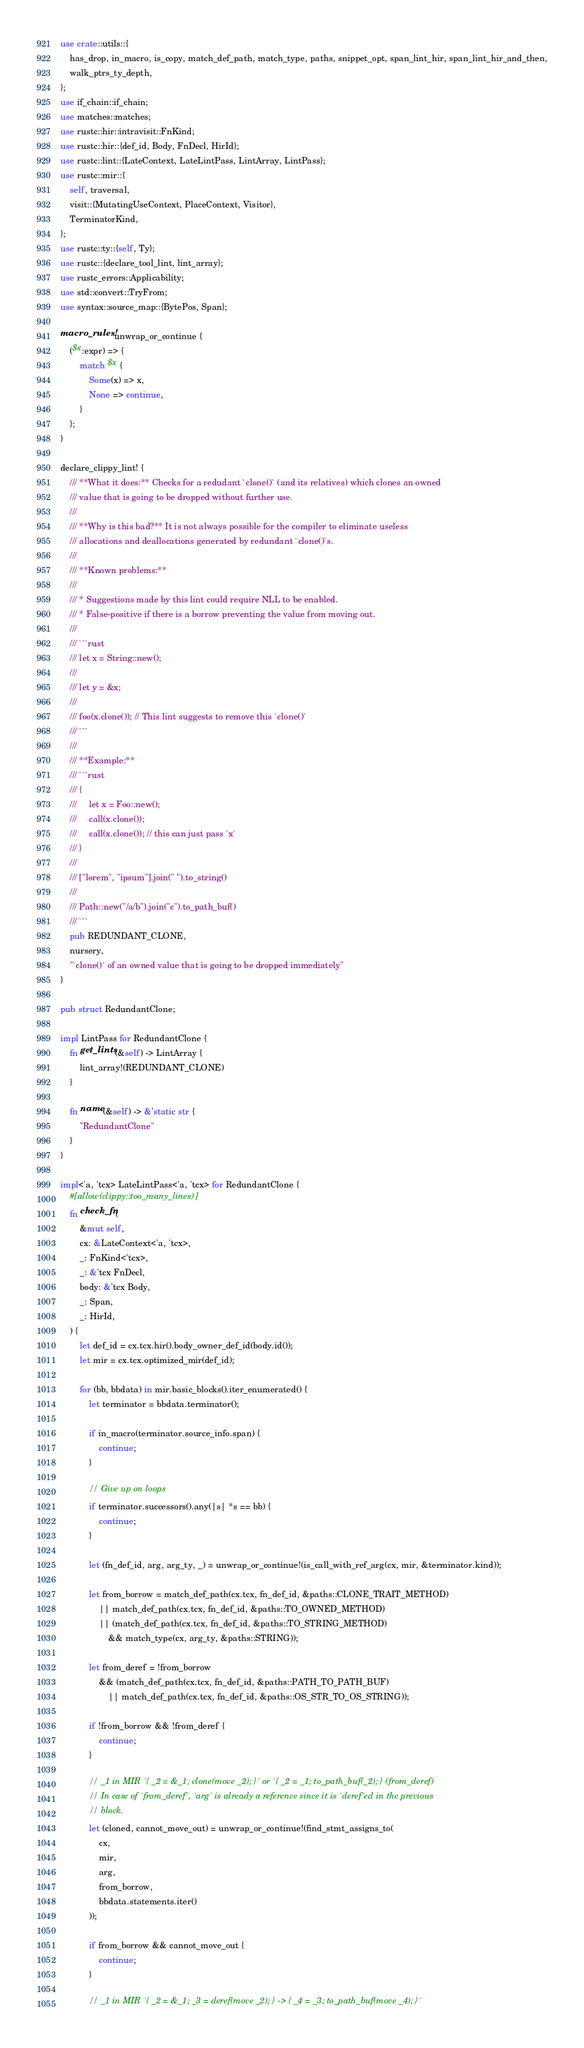<code> <loc_0><loc_0><loc_500><loc_500><_Rust_>use crate::utils::{
    has_drop, in_macro, is_copy, match_def_path, match_type, paths, snippet_opt, span_lint_hir, span_lint_hir_and_then,
    walk_ptrs_ty_depth,
};
use if_chain::if_chain;
use matches::matches;
use rustc::hir::intravisit::FnKind;
use rustc::hir::{def_id, Body, FnDecl, HirId};
use rustc::lint::{LateContext, LateLintPass, LintArray, LintPass};
use rustc::mir::{
    self, traversal,
    visit::{MutatingUseContext, PlaceContext, Visitor},
    TerminatorKind,
};
use rustc::ty::{self, Ty};
use rustc::{declare_tool_lint, lint_array};
use rustc_errors::Applicability;
use std::convert::TryFrom;
use syntax::source_map::{BytePos, Span};

macro_rules! unwrap_or_continue {
    ($x:expr) => {
        match $x {
            Some(x) => x,
            None => continue,
        }
    };
}

declare_clippy_lint! {
    /// **What it does:** Checks for a redudant `clone()` (and its relatives) which clones an owned
    /// value that is going to be dropped without further use.
    ///
    /// **Why is this bad?** It is not always possible for the compiler to eliminate useless
    /// allocations and deallocations generated by redundant `clone()`s.
    ///
    /// **Known problems:**
    ///
    /// * Suggestions made by this lint could require NLL to be enabled.
    /// * False-positive if there is a borrow preventing the value from moving out.
    ///
    /// ```rust
    /// let x = String::new();
    ///
    /// let y = &x;
    ///
    /// foo(x.clone()); // This lint suggests to remove this `clone()`
    /// ```
    ///
    /// **Example:**
    /// ```rust
    /// {
    ///     let x = Foo::new();
    ///     call(x.clone());
    ///     call(x.clone()); // this can just pass `x`
    /// }
    ///
    /// ["lorem", "ipsum"].join(" ").to_string()
    ///
    /// Path::new("/a/b").join("c").to_path_buf()
    /// ```
    pub REDUNDANT_CLONE,
    nursery,
    "`clone()` of an owned value that is going to be dropped immediately"
}

pub struct RedundantClone;

impl LintPass for RedundantClone {
    fn get_lints(&self) -> LintArray {
        lint_array!(REDUNDANT_CLONE)
    }

    fn name(&self) -> &'static str {
        "RedundantClone"
    }
}

impl<'a, 'tcx> LateLintPass<'a, 'tcx> for RedundantClone {
    #[allow(clippy::too_many_lines)]
    fn check_fn(
        &mut self,
        cx: &LateContext<'a, 'tcx>,
        _: FnKind<'tcx>,
        _: &'tcx FnDecl,
        body: &'tcx Body,
        _: Span,
        _: HirId,
    ) {
        let def_id = cx.tcx.hir().body_owner_def_id(body.id());
        let mir = cx.tcx.optimized_mir(def_id);

        for (bb, bbdata) in mir.basic_blocks().iter_enumerated() {
            let terminator = bbdata.terminator();

            if in_macro(terminator.source_info.span) {
                continue;
            }

            // Give up on loops
            if terminator.successors().any(|s| *s == bb) {
                continue;
            }

            let (fn_def_id, arg, arg_ty, _) = unwrap_or_continue!(is_call_with_ref_arg(cx, mir, &terminator.kind));

            let from_borrow = match_def_path(cx.tcx, fn_def_id, &paths::CLONE_TRAIT_METHOD)
                || match_def_path(cx.tcx, fn_def_id, &paths::TO_OWNED_METHOD)
                || (match_def_path(cx.tcx, fn_def_id, &paths::TO_STRING_METHOD)
                    && match_type(cx, arg_ty, &paths::STRING));

            let from_deref = !from_borrow
                && (match_def_path(cx.tcx, fn_def_id, &paths::PATH_TO_PATH_BUF)
                    || match_def_path(cx.tcx, fn_def_id, &paths::OS_STR_TO_OS_STRING));

            if !from_borrow && !from_deref {
                continue;
            }

            // _1 in MIR `{ _2 = &_1; clone(move _2); }` or `{ _2 = _1; to_path_buf(_2); } (from_deref)
            // In case of `from_deref`, `arg` is already a reference since it is `deref`ed in the previous
            // block.
            let (cloned, cannot_move_out) = unwrap_or_continue!(find_stmt_assigns_to(
                cx,
                mir,
                arg,
                from_borrow,
                bbdata.statements.iter()
            ));

            if from_borrow && cannot_move_out {
                continue;
            }

            // _1 in MIR `{ _2 = &_1; _3 = deref(move _2); } -> { _4 = _3; to_path_buf(move _4); }`</code> 